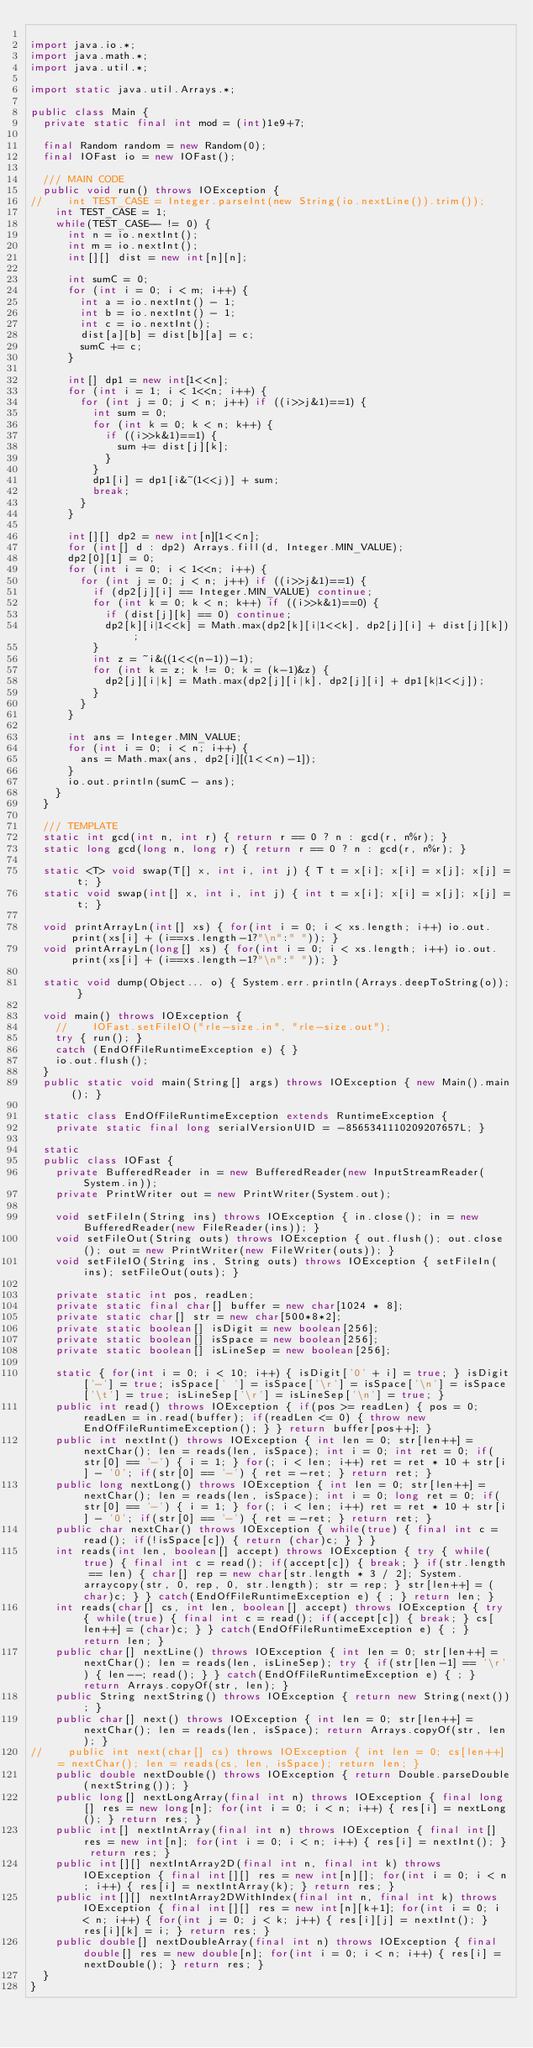Convert code to text. <code><loc_0><loc_0><loc_500><loc_500><_Java_>
import java.io.*;
import java.math.*;
import java.util.*;

import static java.util.Arrays.*;

public class Main {
	private static final int mod = (int)1e9+7;

	final Random random = new Random(0);
	final IOFast io = new IOFast();

	/// MAIN CODE
	public void run() throws IOException {
//		int TEST_CASE = Integer.parseInt(new String(io.nextLine()).trim());
		int TEST_CASE = 1;
		while(TEST_CASE-- != 0) {
			int n = io.nextInt();
			int m = io.nextInt();
			int[][] dist = new int[n][n];
			
			int sumC = 0;
			for (int i = 0; i < m; i++) {
				int a = io.nextInt() - 1;
				int b = io.nextInt() - 1;
				int c = io.nextInt();
				dist[a][b] = dist[b][a] = c;
				sumC += c;
			}
			
			int[] dp1 = new int[1<<n];
			for (int i = 1; i < 1<<n; i++) {
				for (int j = 0; j < n; j++) if ((i>>j&1)==1) {
					int sum = 0;
					for (int k = 0; k < n; k++) {
						if ((i>>k&1)==1) {
							sum += dist[j][k];
						}
					}
					dp1[i] = dp1[i&~(1<<j)] + sum;
					break;
				}
			}
			
			int[][] dp2 = new int[n][1<<n];
			for (int[] d : dp2) Arrays.fill(d, Integer.MIN_VALUE);
			dp2[0][1] = 0;
			for (int i = 0; i < 1<<n; i++) {
				for (int j = 0; j < n; j++) if ((i>>j&1)==1) {
					if (dp2[j][i] == Integer.MIN_VALUE) continue;
					for (int k = 0; k < n; k++) if ((i>>k&1)==0) {
						if (dist[j][k] == 0) continue;
						dp2[k][i|1<<k] = Math.max(dp2[k][i|1<<k], dp2[j][i] + dist[j][k]);
					}
					int z = ~i&((1<<(n-1))-1);
					for (int k = z; k != 0; k = (k-1)&z) {
						dp2[j][i|k] = Math.max(dp2[j][i|k], dp2[j][i] + dp1[k|1<<j]);
					}
				}
			}
			
			int ans = Integer.MIN_VALUE;
			for (int i = 0; i < n; i++) {
				ans = Math.max(ans, dp2[i][(1<<n)-1]);
			}
			io.out.println(sumC - ans);
		}
	}
	
	/// TEMPLATE
	static int gcd(int n, int r) { return r == 0 ? n : gcd(r, n%r); }
	static long gcd(long n, long r) { return r == 0 ? n : gcd(r, n%r); }
	
	static <T> void swap(T[] x, int i, int j) { T t = x[i]; x[i] = x[j]; x[j] = t; }
	static void swap(int[] x, int i, int j) { int t = x[i]; x[i] = x[j]; x[j] = t; }

	void printArrayLn(int[] xs) { for(int i = 0; i < xs.length; i++) io.out.print(xs[i] + (i==xs.length-1?"\n":" ")); }
	void printArrayLn(long[] xs) { for(int i = 0; i < xs.length; i++) io.out.print(xs[i] + (i==xs.length-1?"\n":" ")); }
	
	static void dump(Object... o) { System.err.println(Arrays.deepToString(o)); } 
	
	void main() throws IOException {
		//		IOFast.setFileIO("rle-size.in", "rle-size.out");
		try { run(); }
		catch (EndOfFileRuntimeException e) { }
		io.out.flush();
	}
	public static void main(String[] args) throws IOException { new Main().main(); }
	
	static class EndOfFileRuntimeException extends RuntimeException {
		private static final long serialVersionUID = -8565341110209207657L; }

	static
	public class IOFast {
		private BufferedReader in = new BufferedReader(new InputStreamReader(System.in));
		private PrintWriter out = new PrintWriter(System.out);

		void setFileIn(String ins) throws IOException { in.close(); in = new BufferedReader(new FileReader(ins)); }
		void setFileOut(String outs) throws IOException { out.flush(); out.close(); out = new PrintWriter(new FileWriter(outs)); }
		void setFileIO(String ins, String outs) throws IOException { setFileIn(ins); setFileOut(outs); }

		private static int pos, readLen;
		private static final char[] buffer = new char[1024 * 8];
		private static char[] str = new char[500*8*2];
		private static boolean[] isDigit = new boolean[256];
		private static boolean[] isSpace = new boolean[256];
		private static boolean[] isLineSep = new boolean[256];

		static { for(int i = 0; i < 10; i++) { isDigit['0' + i] = true; } isDigit['-'] = true; isSpace[' '] = isSpace['\r'] = isSpace['\n'] = isSpace['\t'] = true; isLineSep['\r'] = isLineSep['\n'] = true; }
		public int read() throws IOException { if(pos >= readLen) { pos = 0; readLen = in.read(buffer); if(readLen <= 0) { throw new EndOfFileRuntimeException(); } } return buffer[pos++]; }
		public int nextInt() throws IOException { int len = 0; str[len++] = nextChar(); len = reads(len, isSpace); int i = 0; int ret = 0; if(str[0] == '-') { i = 1; } for(; i < len; i++) ret = ret * 10 + str[i] - '0'; if(str[0] == '-') { ret = -ret; } return ret; }
		public long nextLong() throws IOException { int len = 0; str[len++] = nextChar(); len = reads(len, isSpace); int i = 0; long ret = 0; if(str[0] == '-') { i = 1; } for(; i < len; i++) ret = ret * 10 + str[i] - '0'; if(str[0] == '-') { ret = -ret; } return ret; }
		public char nextChar() throws IOException { while(true) { final int c = read(); if(!isSpace[c]) { return (char)c; } } }
		int reads(int len, boolean[] accept) throws IOException { try { while(true) { final int c = read(); if(accept[c]) { break; } if(str.length == len) { char[] rep = new char[str.length * 3 / 2]; System.arraycopy(str, 0, rep, 0, str.length); str = rep; } str[len++] = (char)c; } } catch(EndOfFileRuntimeException e) { ; } return len; }
		int reads(char[] cs, int len, boolean[] accept) throws IOException { try { while(true) { final int c = read(); if(accept[c]) { break; } cs[len++] = (char)c; } } catch(EndOfFileRuntimeException e) { ; } return len; }
		public char[] nextLine() throws IOException { int len = 0; str[len++] = nextChar(); len = reads(len, isLineSep); try { if(str[len-1] == '\r') { len--; read(); } } catch(EndOfFileRuntimeException e) { ; } return Arrays.copyOf(str, len); }
		public String nextString() throws IOException { return new String(next()); }
		public char[] next() throws IOException { int len = 0; str[len++] = nextChar(); len = reads(len, isSpace); return Arrays.copyOf(str, len); }
//		public int next(char[] cs) throws IOException { int len = 0; cs[len++] = nextChar(); len = reads(cs, len, isSpace); return len; }
		public double nextDouble() throws IOException { return Double.parseDouble(nextString()); }
		public long[] nextLongArray(final int n) throws IOException { final long[] res = new long[n]; for(int i = 0; i < n; i++) { res[i] = nextLong(); } return res; }
		public int[] nextIntArray(final int n) throws IOException { final int[] res = new int[n]; for(int i = 0; i < n; i++) { res[i] = nextInt(); } return res; }
		public int[][] nextIntArray2D(final int n, final int k) throws IOException { final int[][] res = new int[n][]; for(int i = 0; i < n; i++) { res[i] = nextIntArray(k); } return res; }
		public int[][] nextIntArray2DWithIndex(final int n, final int k) throws IOException { final int[][] res = new int[n][k+1]; for(int i = 0; i < n; i++) { for(int j = 0; j < k; j++) { res[i][j] = nextInt(); } res[i][k] = i; } return res; }
		public double[] nextDoubleArray(final int n) throws IOException { final double[] res = new double[n]; for(int i = 0; i < n; i++) { res[i] = nextDouble(); } return res; }
	}
}
</code> 